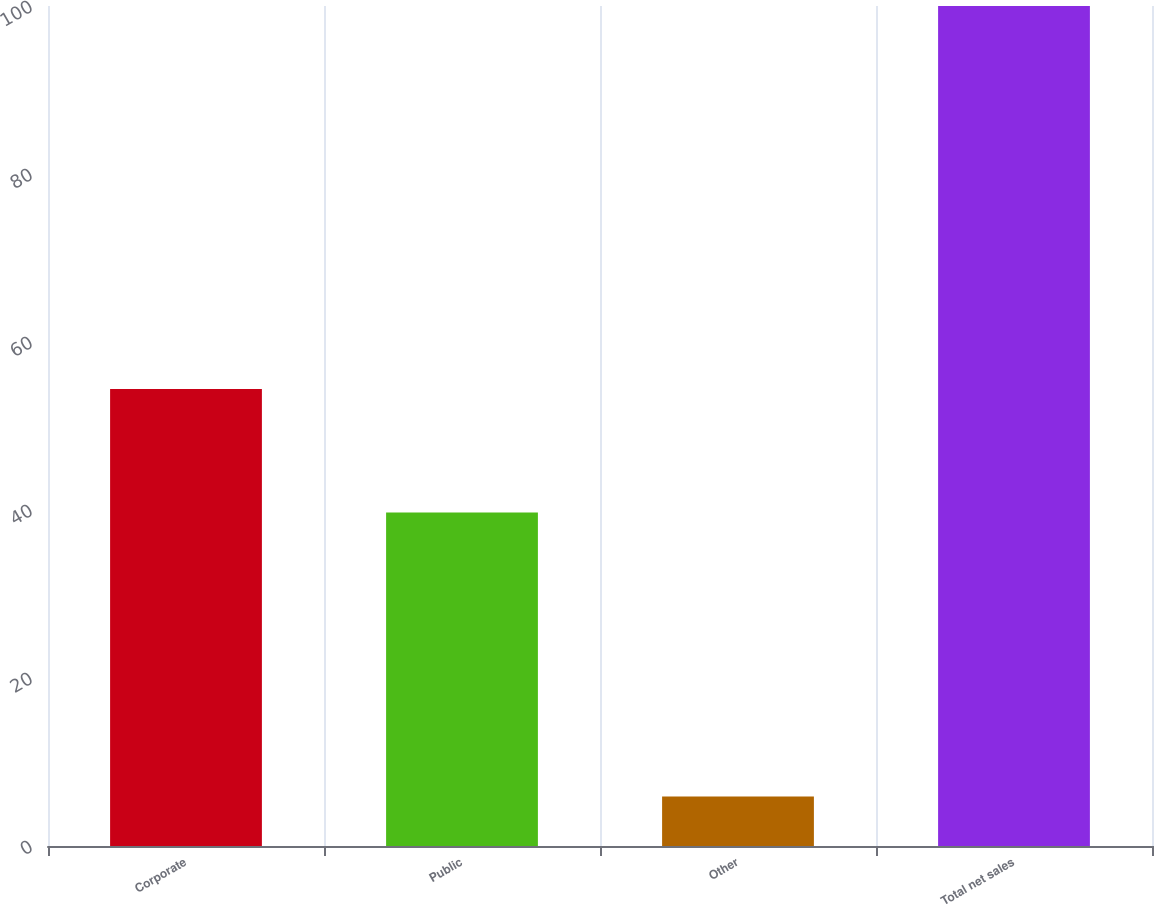<chart> <loc_0><loc_0><loc_500><loc_500><bar_chart><fcel>Corporate<fcel>Public<fcel>Other<fcel>Total net sales<nl><fcel>54.4<fcel>39.7<fcel>5.9<fcel>100<nl></chart> 